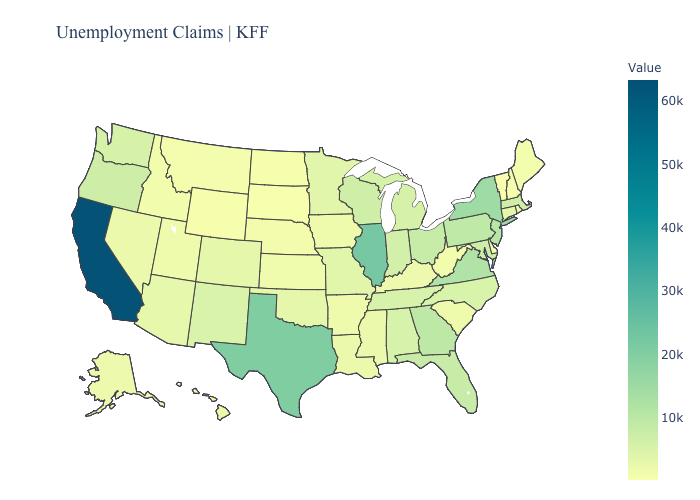Does Oregon have a higher value than New York?
Keep it brief. No. Which states hav the highest value in the West?
Concise answer only. California. Which states have the lowest value in the West?
Short answer required. Wyoming. Does South Dakota have the lowest value in the USA?
Write a very short answer. Yes. 